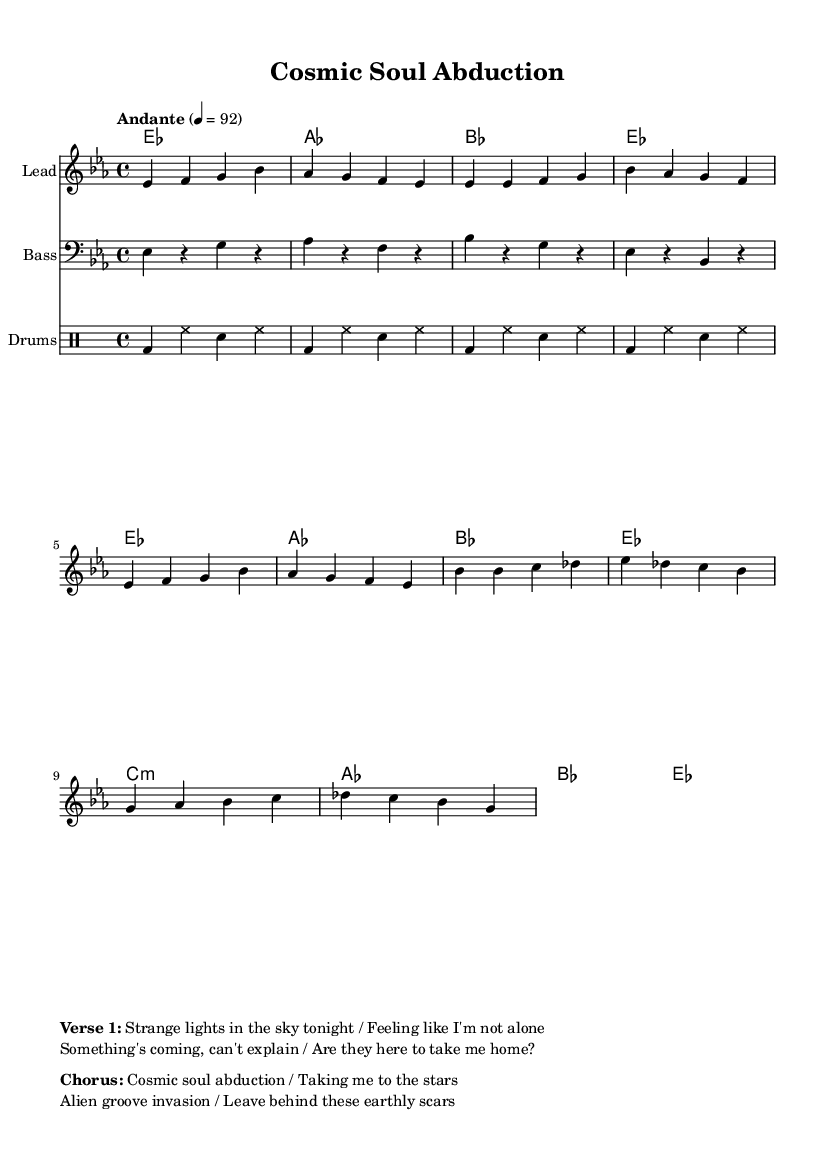What is the key signature of this music? The key signature is indicated by the presence of three flats (B flat, E flat, and A flat), placing it in E flat major.
Answer: E flat major What is the time signature used in this score? The time signature is shown at the beginning of the score with the notation 4/4, which means there are four beats per measure.
Answer: 4/4 What is the tempo marking for this piece? The tempo marking is specified as "Andante" with a beat of 92, providing the speed and feel for the performance.
Answer: Andante 92 How many measures are in the chorus section? By analyzing the score, the chorus section consists of a total of four measures.
Answer: Four measures What is the primary theme of the lyrics in the verse? The verse discusses feelings of alien encounters and a sense of being watched, aligning with the cosmic narrative presented throughout the song.
Answer: Alien encounters What type of rhythm do the drums primarily use throughout the piece? The drum part features a basic four-beat pattern predominantly using bass drum hits followed by hi-hat and snare placements that keep the groove steady and laid-back, characteristic of soul music.
Answer: Basic four-beat pattern What is the unique aspect of the song’s subject matter that relates to soul music? The song uniquely incorporates themes of cosmic exploration and alien experiences, which is atypical for traditional soul music that typically focuses on love, identity, and social issues.
Answer: Cosmic exploration and alien experiences 